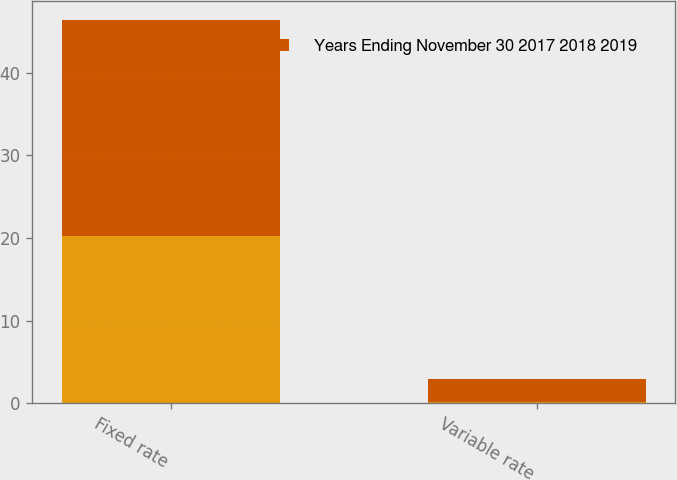Convert chart. <chart><loc_0><loc_0><loc_500><loc_500><stacked_bar_chart><ecel><fcel>Fixed rate<fcel>Variable rate<nl><fcel>nan<fcel>20.2<fcel>0.1<nl><fcel>Years Ending November 30 2017 2018 2019<fcel>26.2<fcel>2.9<nl></chart> 